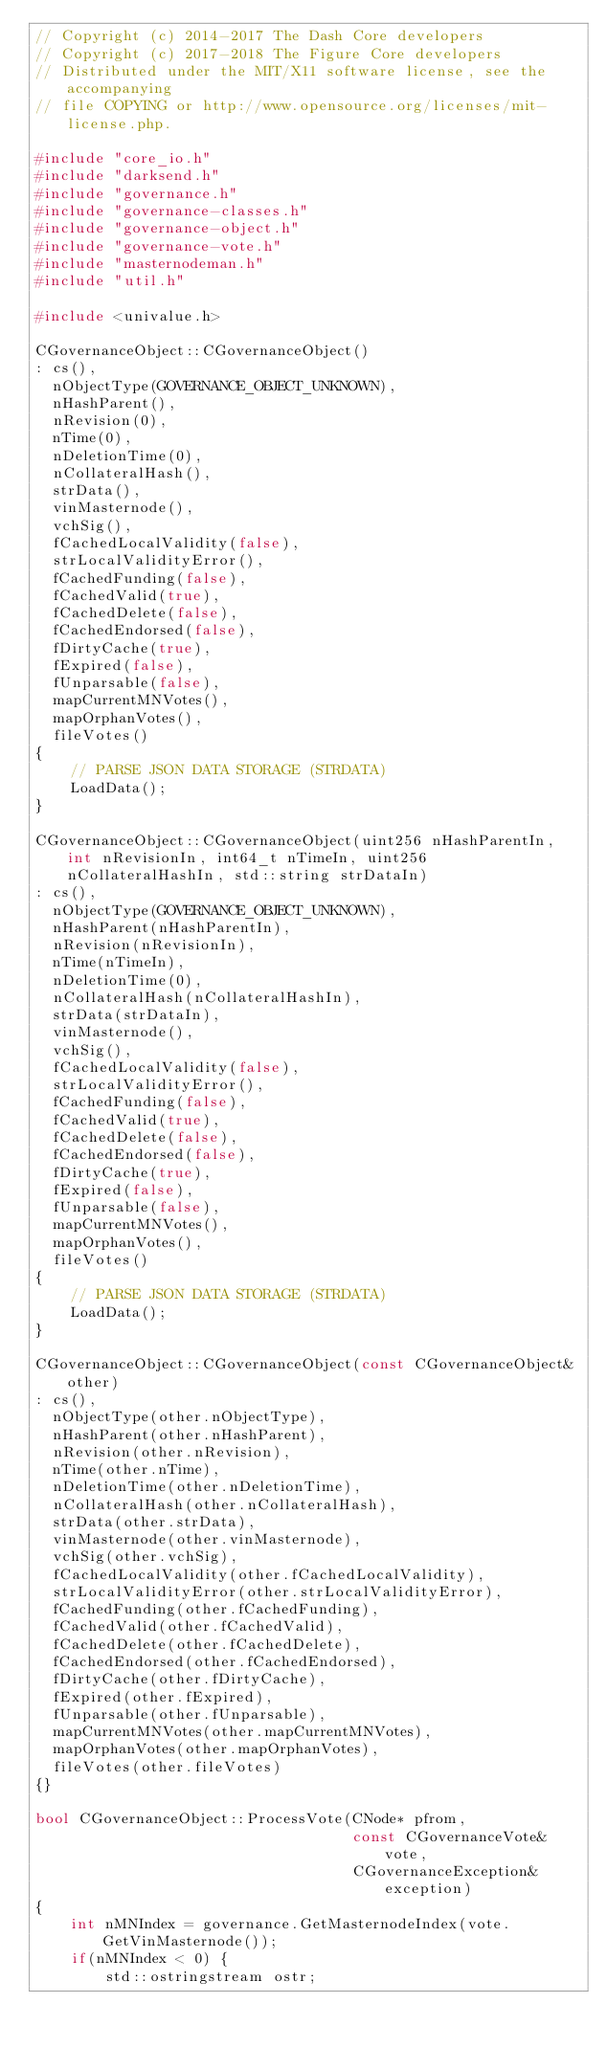<code> <loc_0><loc_0><loc_500><loc_500><_C++_>// Copyright (c) 2014-2017 The Dash Core developers
// Copyright (c) 2017-2018 The Figure Core developers
// Distributed under the MIT/X11 software license, see the accompanying
// file COPYING or http://www.opensource.org/licenses/mit-license.php.

#include "core_io.h"
#include "darksend.h"
#include "governance.h"
#include "governance-classes.h"
#include "governance-object.h"
#include "governance-vote.h"
#include "masternodeman.h"
#include "util.h"

#include <univalue.h>

CGovernanceObject::CGovernanceObject()
: cs(),
  nObjectType(GOVERNANCE_OBJECT_UNKNOWN),
  nHashParent(),
  nRevision(0),
  nTime(0),
  nDeletionTime(0),
  nCollateralHash(),
  strData(),
  vinMasternode(),
  vchSig(),
  fCachedLocalValidity(false),
  strLocalValidityError(),
  fCachedFunding(false),
  fCachedValid(true),
  fCachedDelete(false),
  fCachedEndorsed(false),
  fDirtyCache(true),
  fExpired(false),
  fUnparsable(false),
  mapCurrentMNVotes(),
  mapOrphanVotes(),
  fileVotes()
{
    // PARSE JSON DATA STORAGE (STRDATA)
    LoadData();
}

CGovernanceObject::CGovernanceObject(uint256 nHashParentIn, int nRevisionIn, int64_t nTimeIn, uint256 nCollateralHashIn, std::string strDataIn)
: cs(),
  nObjectType(GOVERNANCE_OBJECT_UNKNOWN),
  nHashParent(nHashParentIn),
  nRevision(nRevisionIn),
  nTime(nTimeIn),
  nDeletionTime(0),
  nCollateralHash(nCollateralHashIn),
  strData(strDataIn),
  vinMasternode(),
  vchSig(),
  fCachedLocalValidity(false),
  strLocalValidityError(),
  fCachedFunding(false),
  fCachedValid(true),
  fCachedDelete(false),
  fCachedEndorsed(false),
  fDirtyCache(true),
  fExpired(false),
  fUnparsable(false),
  mapCurrentMNVotes(),
  mapOrphanVotes(),
  fileVotes()
{
    // PARSE JSON DATA STORAGE (STRDATA)
    LoadData();
}

CGovernanceObject::CGovernanceObject(const CGovernanceObject& other)
: cs(),
  nObjectType(other.nObjectType),
  nHashParent(other.nHashParent),
  nRevision(other.nRevision),
  nTime(other.nTime),
  nDeletionTime(other.nDeletionTime),
  nCollateralHash(other.nCollateralHash),
  strData(other.strData),
  vinMasternode(other.vinMasternode),
  vchSig(other.vchSig),
  fCachedLocalValidity(other.fCachedLocalValidity),
  strLocalValidityError(other.strLocalValidityError),
  fCachedFunding(other.fCachedFunding),
  fCachedValid(other.fCachedValid),
  fCachedDelete(other.fCachedDelete),
  fCachedEndorsed(other.fCachedEndorsed),
  fDirtyCache(other.fDirtyCache),
  fExpired(other.fExpired),
  fUnparsable(other.fUnparsable),
  mapCurrentMNVotes(other.mapCurrentMNVotes),
  mapOrphanVotes(other.mapOrphanVotes),
  fileVotes(other.fileVotes)
{}

bool CGovernanceObject::ProcessVote(CNode* pfrom,
                                    const CGovernanceVote& vote,
                                    CGovernanceException& exception)
{
    int nMNIndex = governance.GetMasternodeIndex(vote.GetVinMasternode());
    if(nMNIndex < 0) {
        std::ostringstream ostr;</code> 